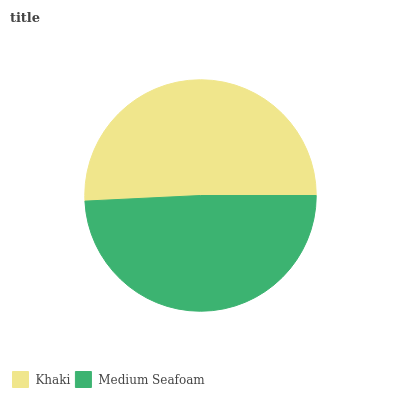Is Medium Seafoam the minimum?
Answer yes or no. Yes. Is Khaki the maximum?
Answer yes or no. Yes. Is Medium Seafoam the maximum?
Answer yes or no. No. Is Khaki greater than Medium Seafoam?
Answer yes or no. Yes. Is Medium Seafoam less than Khaki?
Answer yes or no. Yes. Is Medium Seafoam greater than Khaki?
Answer yes or no. No. Is Khaki less than Medium Seafoam?
Answer yes or no. No. Is Khaki the high median?
Answer yes or no. Yes. Is Medium Seafoam the low median?
Answer yes or no. Yes. Is Medium Seafoam the high median?
Answer yes or no. No. Is Khaki the low median?
Answer yes or no. No. 